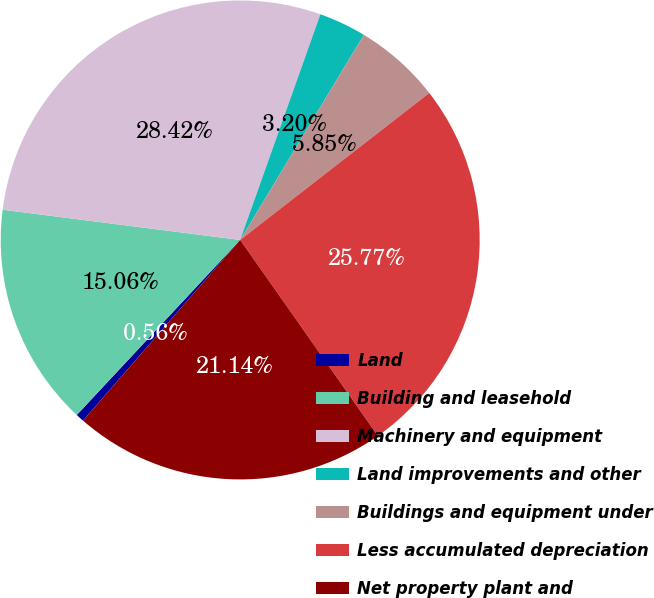<chart> <loc_0><loc_0><loc_500><loc_500><pie_chart><fcel>Land<fcel>Building and leasehold<fcel>Machinery and equipment<fcel>Land improvements and other<fcel>Buildings and equipment under<fcel>Less accumulated depreciation<fcel>Net property plant and<nl><fcel>0.56%<fcel>15.06%<fcel>28.42%<fcel>3.2%<fcel>5.85%<fcel>25.77%<fcel>21.14%<nl></chart> 